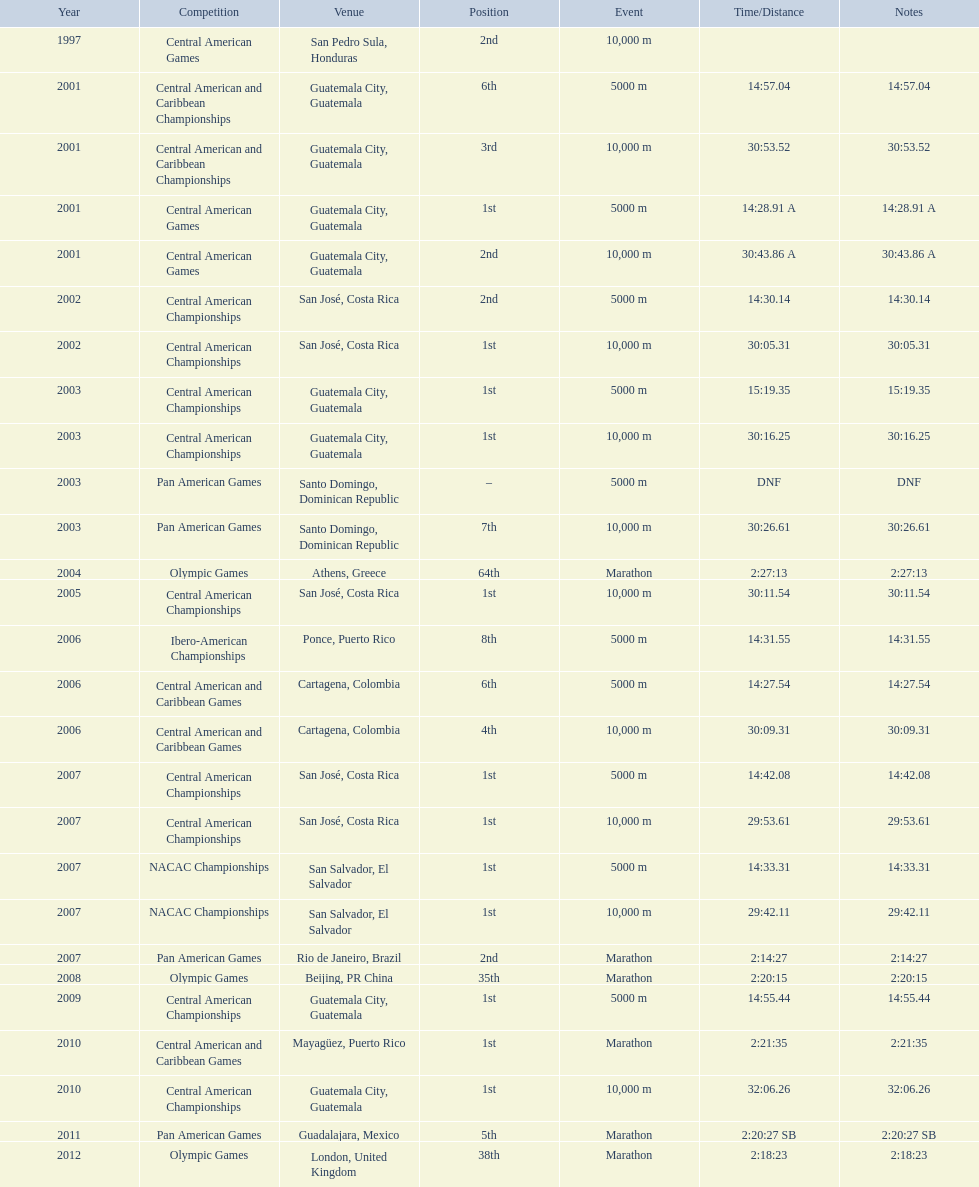What was the first competition this competitor competed in? Central American Games. 